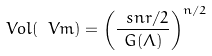Convert formula to latex. <formula><loc_0><loc_0><loc_500><loc_500>V o l ( \ V m ) = \left ( \frac { \ s n r / 2 } { G ( \Lambda ) } \right ) ^ { n / 2 }</formula> 